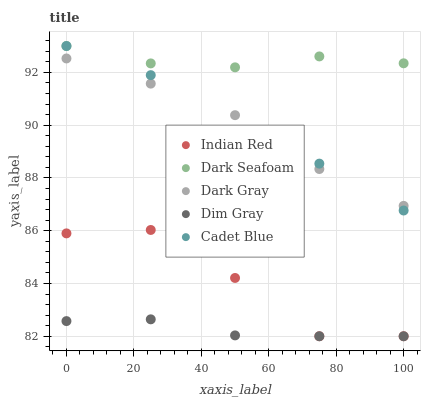Does Dim Gray have the minimum area under the curve?
Answer yes or no. Yes. Does Dark Seafoam have the maximum area under the curve?
Answer yes or no. Yes. Does Dark Seafoam have the minimum area under the curve?
Answer yes or no. No. Does Dim Gray have the maximum area under the curve?
Answer yes or no. No. Is Dim Gray the smoothest?
Answer yes or no. Yes. Is Indian Red the roughest?
Answer yes or no. Yes. Is Dark Seafoam the smoothest?
Answer yes or no. No. Is Dark Seafoam the roughest?
Answer yes or no. No. Does Dim Gray have the lowest value?
Answer yes or no. Yes. Does Dark Seafoam have the lowest value?
Answer yes or no. No. Does Cadet Blue have the highest value?
Answer yes or no. Yes. Does Dim Gray have the highest value?
Answer yes or no. No. Is Indian Red less than Dark Gray?
Answer yes or no. Yes. Is Dark Gray greater than Dim Gray?
Answer yes or no. Yes. Does Indian Red intersect Dim Gray?
Answer yes or no. Yes. Is Indian Red less than Dim Gray?
Answer yes or no. No. Is Indian Red greater than Dim Gray?
Answer yes or no. No. Does Indian Red intersect Dark Gray?
Answer yes or no. No. 